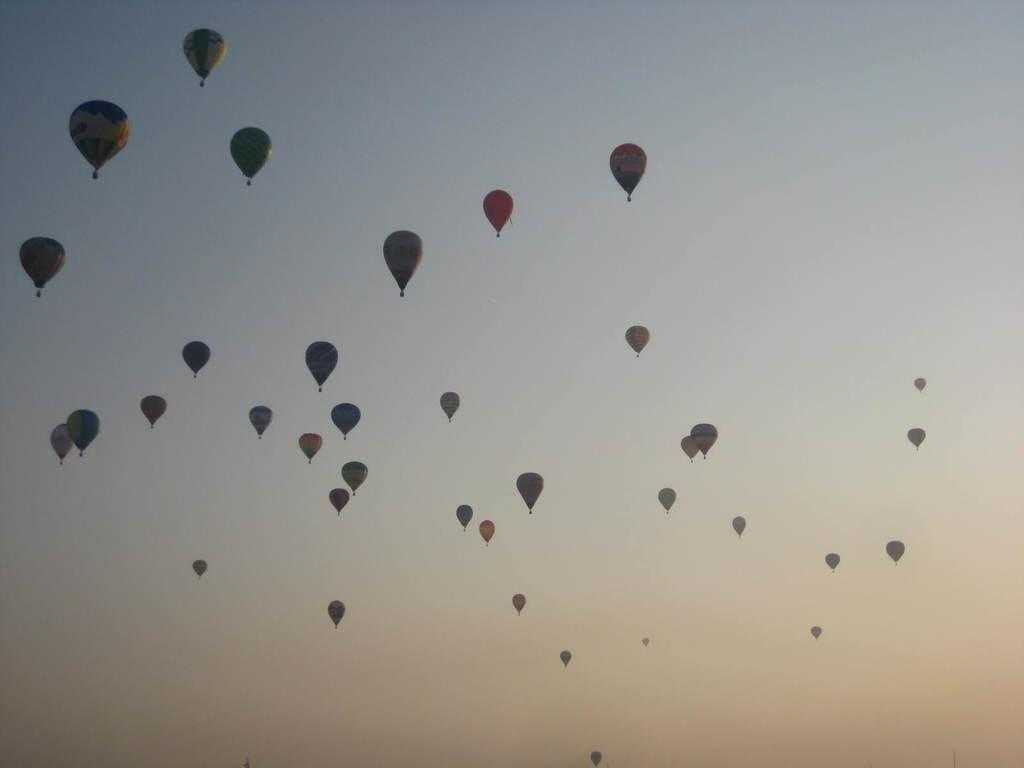What is the main subject of the image? The main subject of the image is hot air balloons. Where are the hot air balloons located in the image? The hot air balloons are in the air. What can be seen in the background of the image? There is sky visible in the background of the image. What type of stamp can be seen on the arm of the person in the image? There is no person present in the image, and therefore no stamp or arm can be observed. 